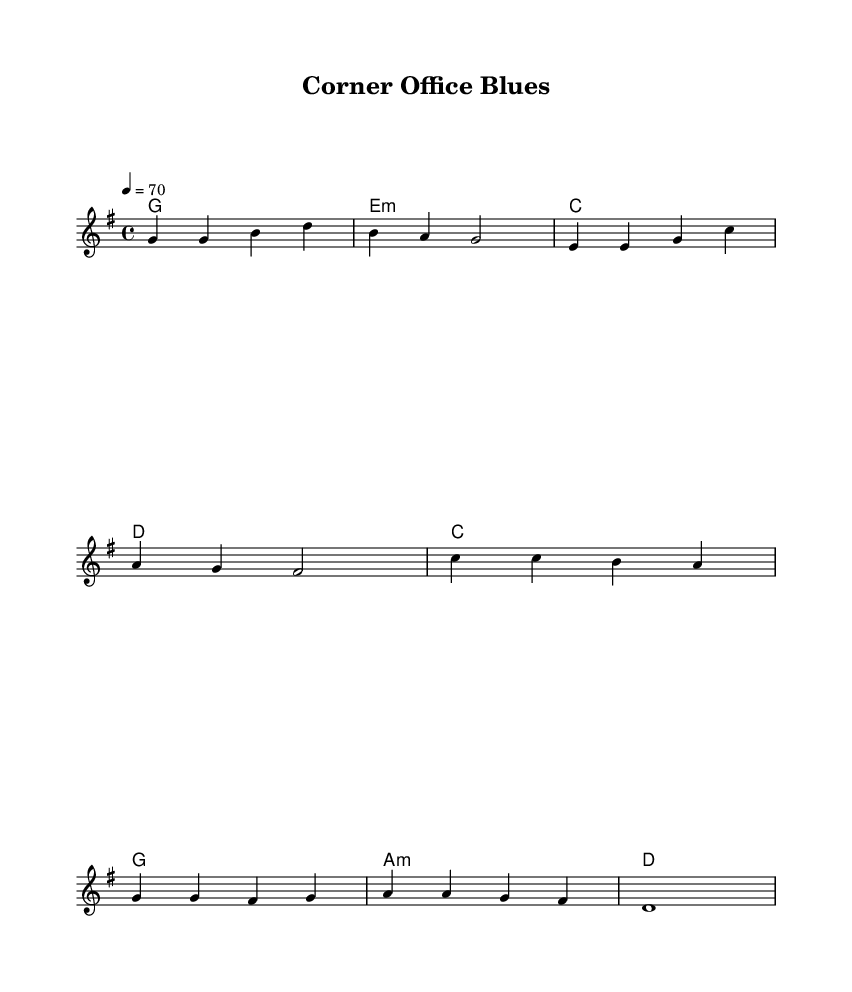What is the key signature of this music? The key signature is G major, which has one sharp (F#). This is indicated at the beginning of the staff where the sharps are placed.
Answer: G major What is the time signature of this music? The time signature is 4/4, which is usually represented at the beginning of the score. It indicates that there are four beats in a measure and a quarter note gets one beat.
Answer: 4/4 What is the tempo marking for this piece? The tempo marking is 4 = 70, which means there are 70 beats per minute based on the quarter note. This is usually found in the text that sets the speed of the piece at the beginning.
Answer: 70 How many measures are in the verse section? The verse section contains 4 measures, which can be counted by the number of vertical lines separating the groups of notes in that section.
Answer: 4 What type of chord is used for the first measure of the verse? The first measure of the verse has a G major chord, indicated by the chord name below the staff. This shows the harmony that accompanies the melody.
Answer: G What is the primary theme explored in the lyrics of this song? The primary theme is the conflict between professional success and personal fulfillment, as indicated by the lyrics that describe feelings of sadness despite climbing the corporate ladder.
Answer: Balance What is the overall mood conveyed by the chorus? The overall mood conveyed in the chorus is one of longing or dissatisfaction, as it reflects the realization that success on paper does not equate to true happiness. This mood can be detected through the lyrical content and melody.
Answer: Longing 